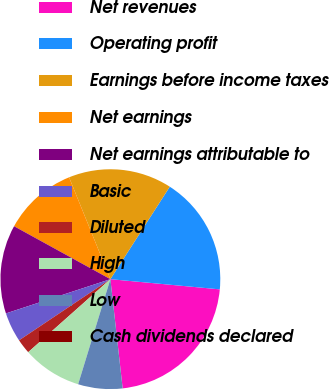<chart> <loc_0><loc_0><loc_500><loc_500><pie_chart><fcel>Net revenues<fcel>Operating profit<fcel>Earnings before income taxes<fcel>Net earnings<fcel>Net earnings attributable to<fcel>Basic<fcel>Diluted<fcel>High<fcel>Low<fcel>Cash dividends declared<nl><fcel>21.74%<fcel>17.39%<fcel>15.22%<fcel>10.87%<fcel>13.04%<fcel>4.35%<fcel>2.17%<fcel>8.7%<fcel>6.52%<fcel>0.0%<nl></chart> 